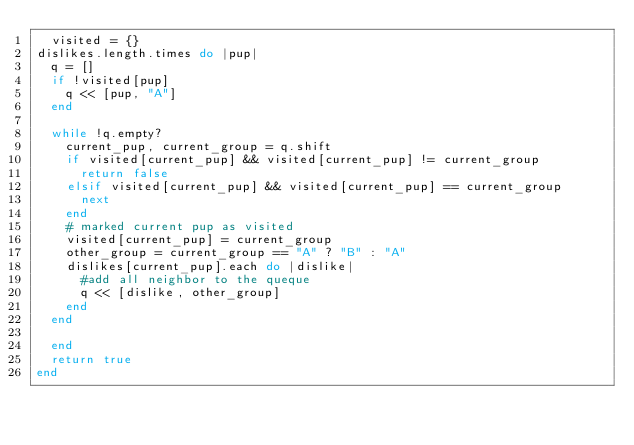Convert code to text. <code><loc_0><loc_0><loc_500><loc_500><_Ruby_>  visited = {}
dislikes.length.times do |pup|
  q = []
  if !visited[pup]
    q << [pup, "A"]
  end

  while !q.empty?
    current_pup, current_group = q.shift
    if visited[current_pup] && visited[current_pup] != current_group
      return false
    elsif visited[current_pup] && visited[current_pup] == current_group
      next
    end
    # marked current pup as visited
    visited[current_pup] = current_group
    other_group = current_group == "A" ? "B" : "A" 
    dislikes[current_pup].each do |dislike|
      #add all neighbor to the queque
      q << [dislike, other_group]
    end
  end

  end
  return true
end
</code> 